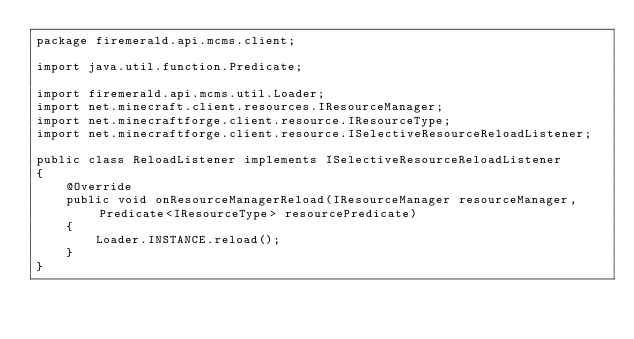<code> <loc_0><loc_0><loc_500><loc_500><_Java_>package firemerald.api.mcms.client;

import java.util.function.Predicate;

import firemerald.api.mcms.util.Loader;
import net.minecraft.client.resources.IResourceManager;
import net.minecraftforge.client.resource.IResourceType;
import net.minecraftforge.client.resource.ISelectiveResourceReloadListener;

public class ReloadListener implements ISelectiveResourceReloadListener
{
	@Override
	public void onResourceManagerReload(IResourceManager resourceManager, Predicate<IResourceType> resourcePredicate)
	{
		Loader.INSTANCE.reload();
	}
}</code> 